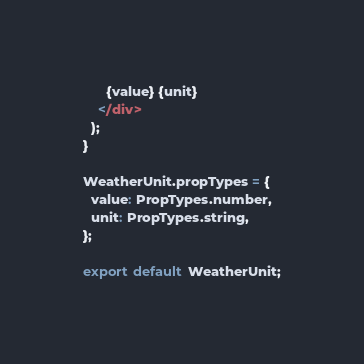Convert code to text. <code><loc_0><loc_0><loc_500><loc_500><_JavaScript_>      {value} {unit}
    </div>
  );
}

WeatherUnit.propTypes = {
  value: PropTypes.number,
  unit: PropTypes.string,
};

export default WeatherUnit;
</code> 